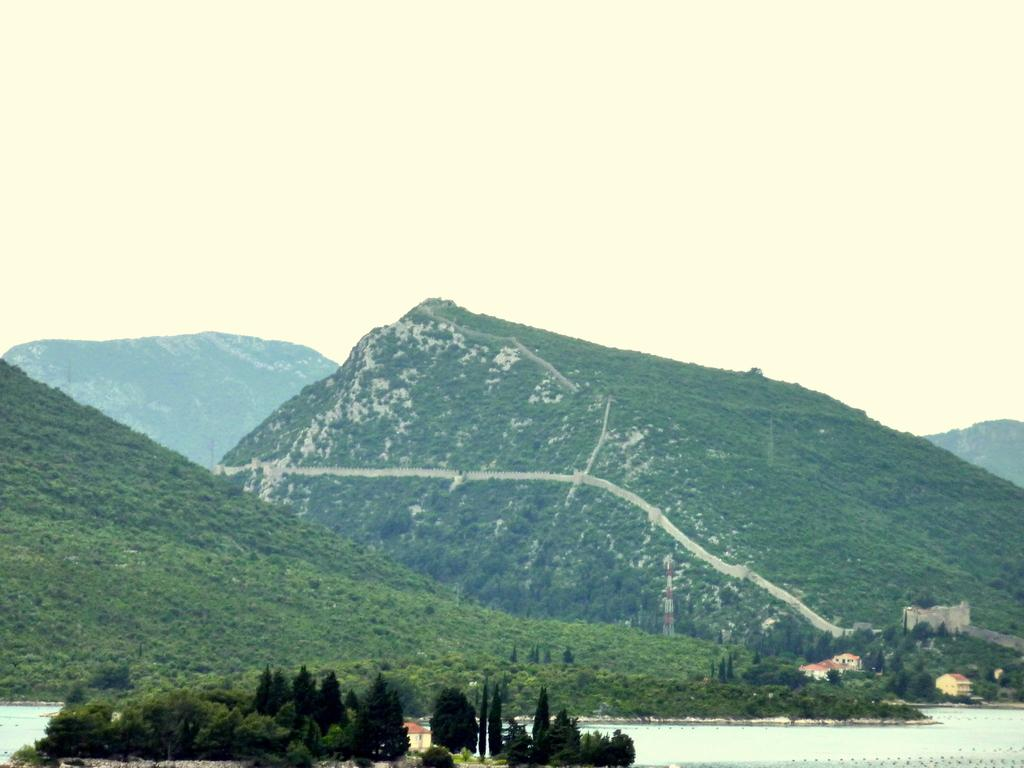What type of natural features can be seen in the image? There are trees, mountains, and a river visible in the image. What part of the natural environment is visible in the sky? The sky is visible in the image. What type of collar can be seen on the toys in the image? There are no toys or collars present in the image. 